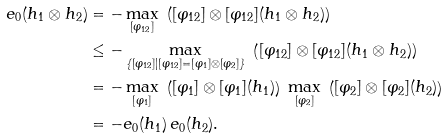<formula> <loc_0><loc_0><loc_500><loc_500>e _ { 0 } ( h _ { 1 } \otimes h _ { 2 } ) & = - \max _ { [ \varphi _ { 1 2 } ] } \ \left ( [ \varphi _ { 1 2 } ] \otimes [ \varphi _ { 1 2 } ] ( h _ { 1 } \otimes h _ { 2 } ) \right ) \\ & \leq - \max _ { \{ [ \varphi _ { 1 2 } ] | [ \varphi _ { 1 2 } ] = [ \varphi _ { 1 } ] \otimes [ \varphi _ { 2 } ] \} } \ \left ( [ \varphi _ { 1 2 } ] \otimes [ \varphi _ { 1 2 } ] ( h _ { 1 } \otimes h _ { 2 } ) \right ) \\ & = - \max _ { [ \varphi _ { 1 } ] } \ \left ( [ \varphi _ { 1 } ] \otimes [ \varphi _ { 1 } ] ( h _ { 1 } ) \right ) \ \max _ { [ \varphi _ { 2 } ] } \ \left ( [ \varphi _ { 2 } ] \otimes [ \varphi _ { 2 } ] ( h _ { 2 } ) \right ) \\ & = - e _ { 0 } ( h _ { 1 } ) \, e _ { 0 } ( h _ { 2 } ) .</formula> 